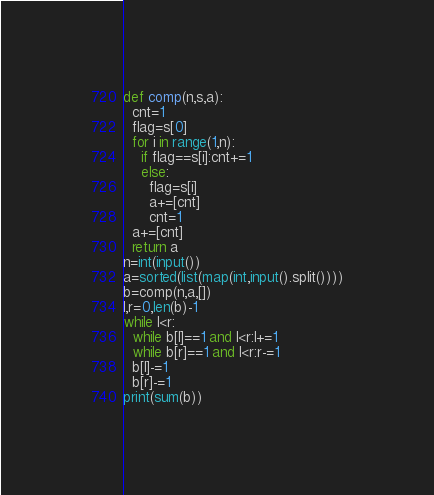<code> <loc_0><loc_0><loc_500><loc_500><_Python_>def comp(n,s,a):
  cnt=1
  flag=s[0]
  for i in range(1,n):
    if flag==s[i]:cnt+=1
    else:
      flag=s[i]
      a+=[cnt]
      cnt=1
  a+=[cnt]
  return a
n=int(input())
a=sorted(list(map(int,input().split())))
b=comp(n,a,[])
l,r=0,len(b)-1
while l<r:
  while b[l]==1 and l<r:l+=1
  while b[r]==1 and l<r:r-=1
  b[l]-=1
  b[r]-=1
print(sum(b))</code> 